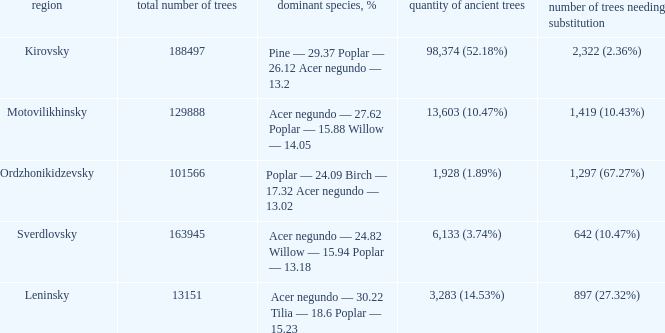What is the amount of trees, that require replacement when district is leninsky? 897 (27.32%). 